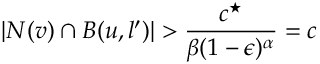Convert formula to latex. <formula><loc_0><loc_0><loc_500><loc_500>| N ( v ) \cap B ( u , l ^ { \prime } ) | > \frac { c ^ { ^ { * } } } { \beta ( 1 - \epsilon ) ^ { \alpha } } = c</formula> 